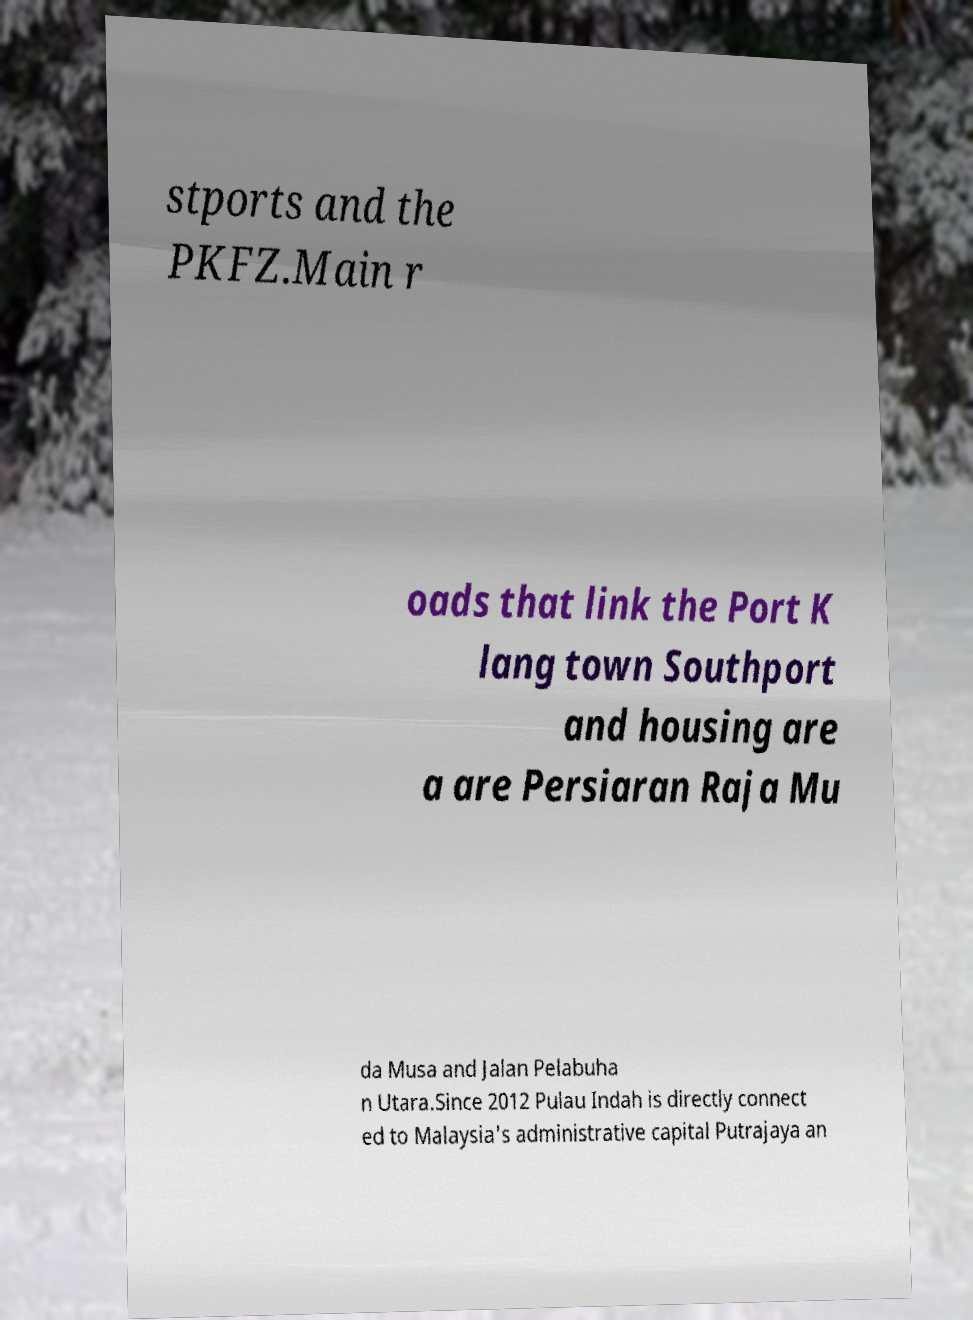What messages or text are displayed in this image? I need them in a readable, typed format. stports and the PKFZ.Main r oads that link the Port K lang town Southport and housing are a are Persiaran Raja Mu da Musa and Jalan Pelabuha n Utara.Since 2012 Pulau Indah is directly connect ed to Malaysia's administrative capital Putrajaya an 